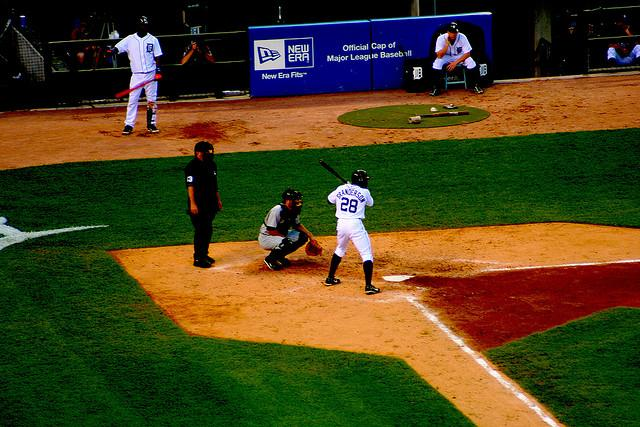The person wearing what color of shirt officiates the game?

Choices:
A) blue
B) white
C) grey
D) black black 